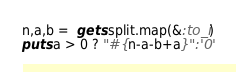Convert code to text. <code><loc_0><loc_0><loc_500><loc_500><_Ruby_>n,a,b =  gets.split.map(&:to_i)
puts a > 0 ? "#{n-a-b+a}":'0'</code> 